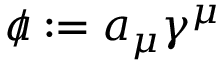Convert formula to latex. <formula><loc_0><loc_0><loc_500><loc_500>a \, / \colon = a _ { \mu } \gamma ^ { \mu }</formula> 